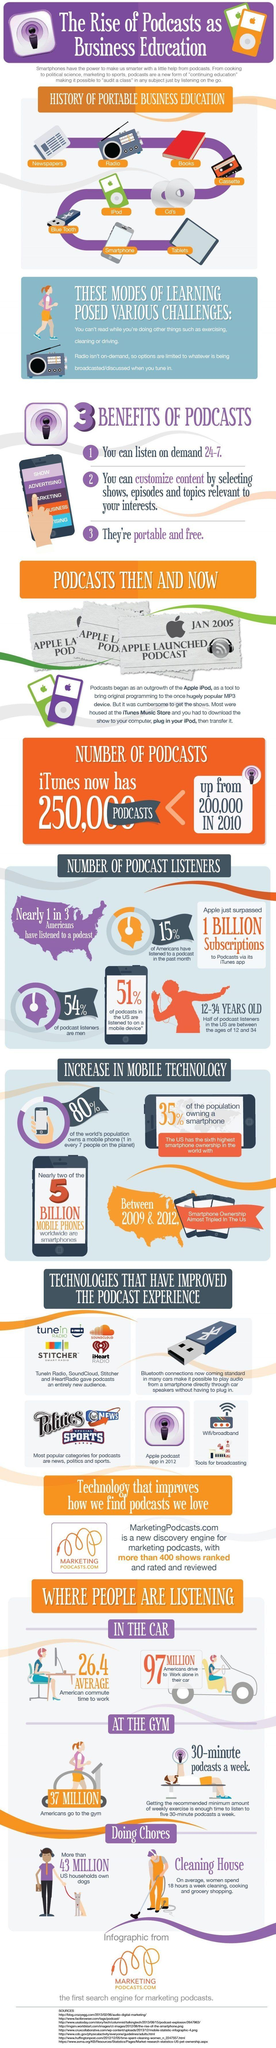Draw attention to some important aspects in this diagram. According to recent estimates, approximately 37 MILLION Americans regularly visit gyms or fitness centers. According to recent studies, approximately 20% of the world's population does not own a mobile phone. As of 2010, the number of podcasts available on iTunes was approximately 200,000. The average American commute time to work is approximately 26.4 minutes. According to a study, women make up 46% of podcast listeners in America. 